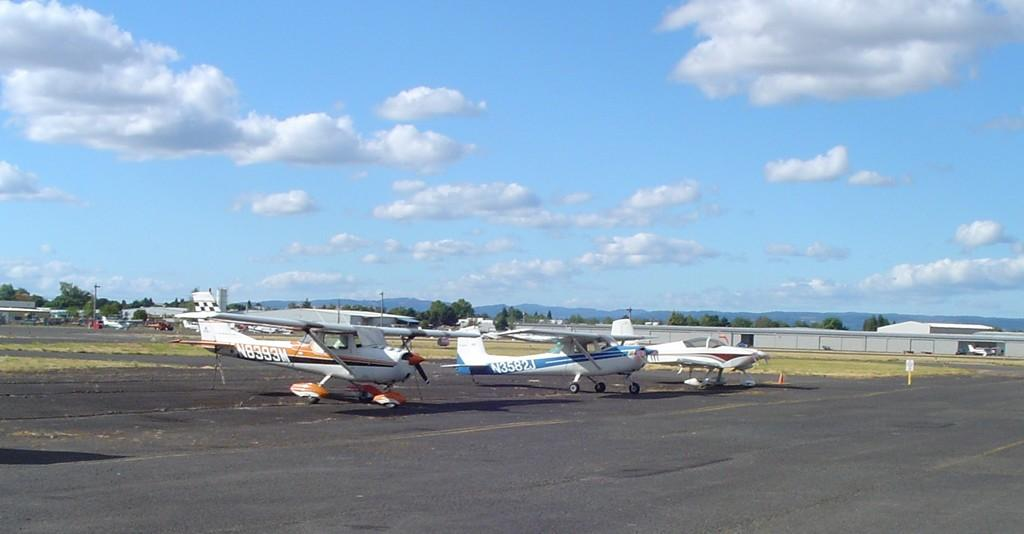Provide a one-sentence caption for the provided image. two airplanes marked N8393M andN3582J are sitting side by side. 